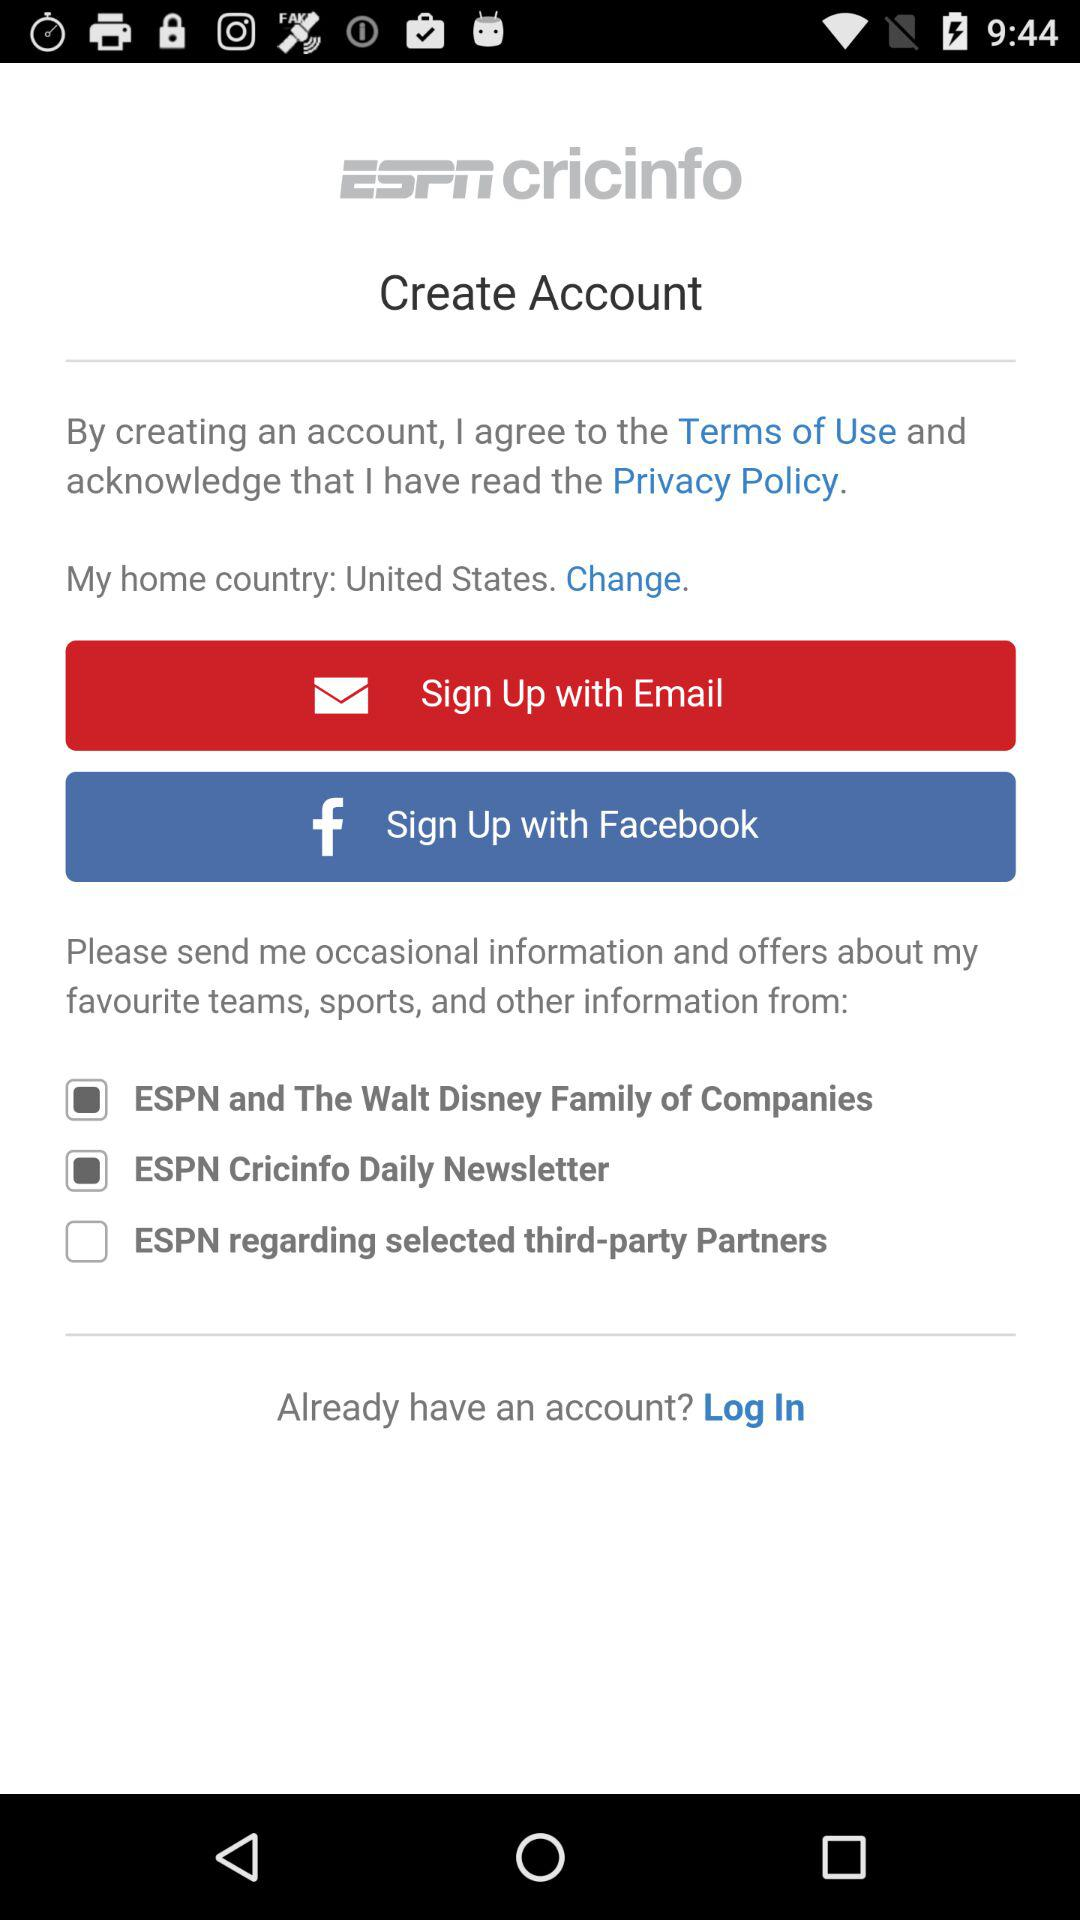What is the application name? The application name is "ESPNcricinfo". 